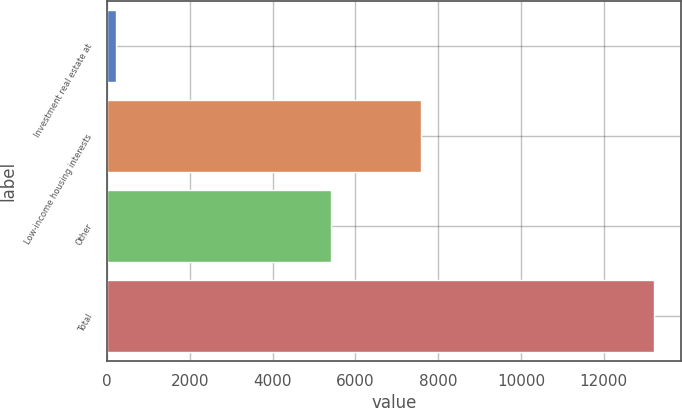<chart> <loc_0><loc_0><loc_500><loc_500><bar_chart><fcel>Investment real estate at<fcel>Low-income housing interests<fcel>Other<fcel>Total<nl><fcel>203<fcel>7589<fcel>5415<fcel>13207<nl></chart> 